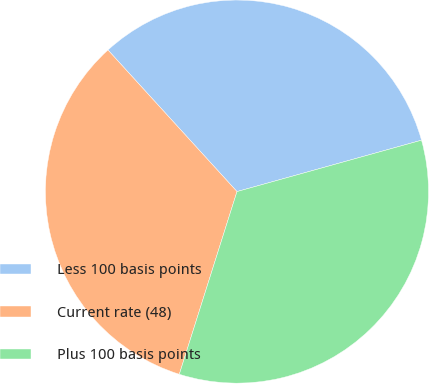Convert chart. <chart><loc_0><loc_0><loc_500><loc_500><pie_chart><fcel>Less 100 basis points<fcel>Current rate (48)<fcel>Plus 100 basis points<nl><fcel>32.44%<fcel>33.37%<fcel>34.19%<nl></chart> 